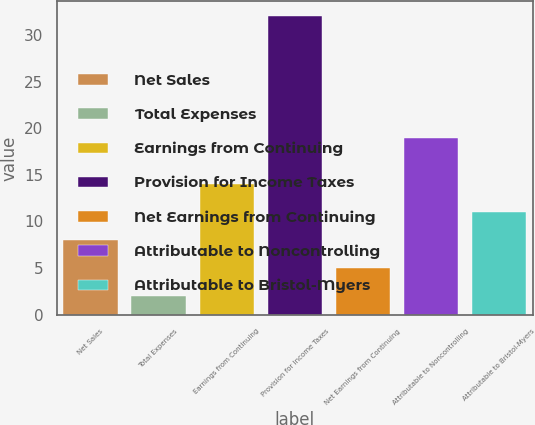<chart> <loc_0><loc_0><loc_500><loc_500><bar_chart><fcel>Net Sales<fcel>Total Expenses<fcel>Earnings from Continuing<fcel>Provision for Income Taxes<fcel>Net Earnings from Continuing<fcel>Attributable to Noncontrolling<fcel>Attributable to Bristol-Myers<nl><fcel>8<fcel>2<fcel>14<fcel>32<fcel>5<fcel>19<fcel>11<nl></chart> 